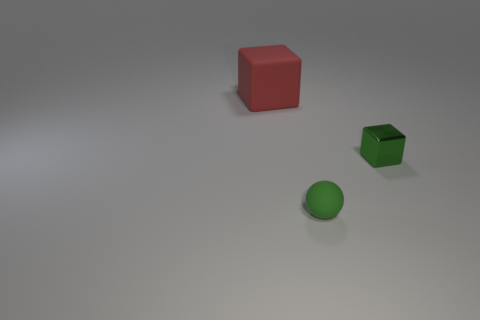What can you say about the lighting and shadows in the scene? The lighting in the scene appears to be coming from above as indicated by the shadows beneath the objects. The shadows are soft and diffused, suggesting the light source isn't very close to the objects. This lighting creates a calm and muted atmosphere. 